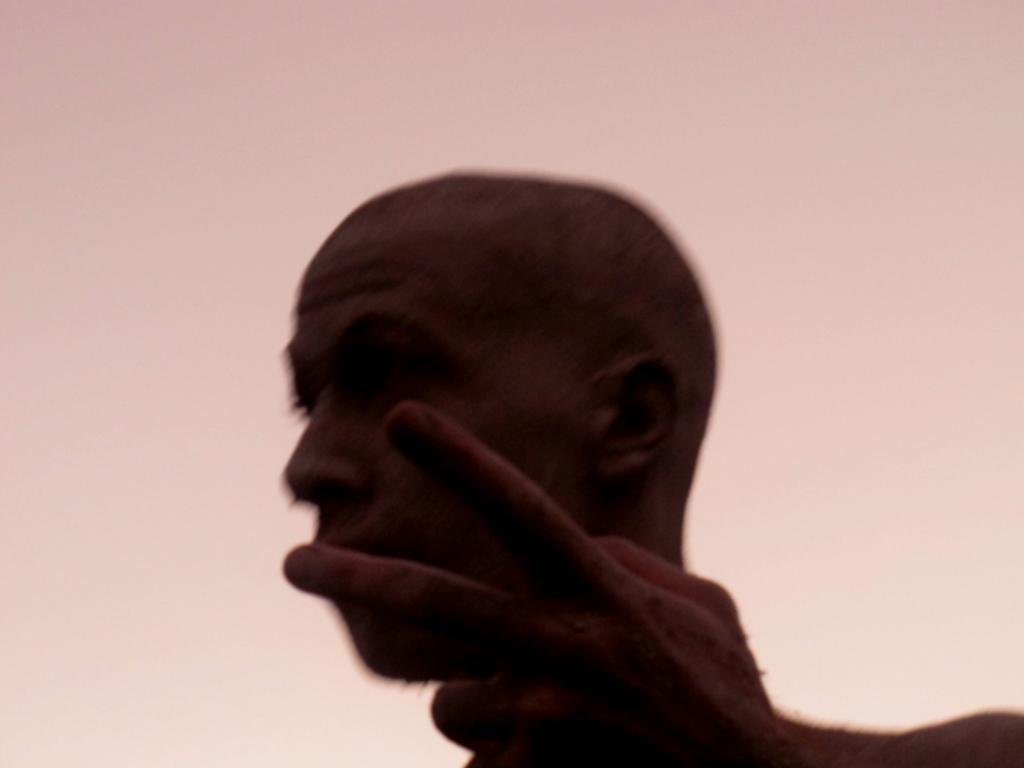How would you summarize this image in a sentence or two? In this image I can see a person and the pink and cream colored background. 